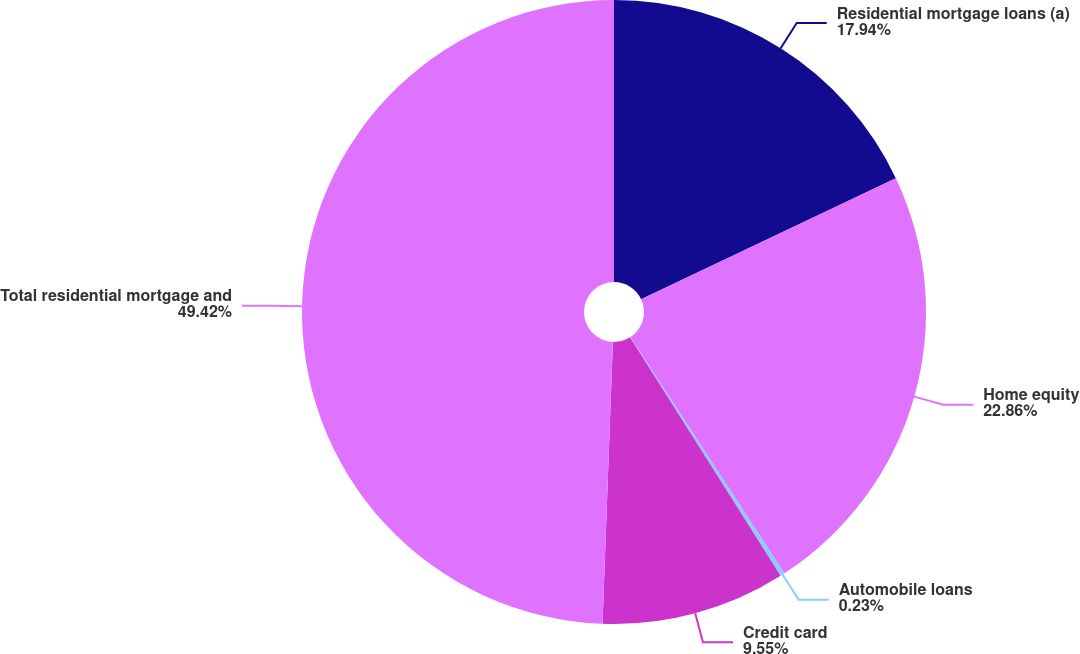<chart> <loc_0><loc_0><loc_500><loc_500><pie_chart><fcel>Residential mortgage loans (a)<fcel>Home equity<fcel>Automobile loans<fcel>Credit card<fcel>Total residential mortgage and<nl><fcel>17.94%<fcel>22.86%<fcel>0.23%<fcel>9.55%<fcel>49.41%<nl></chart> 